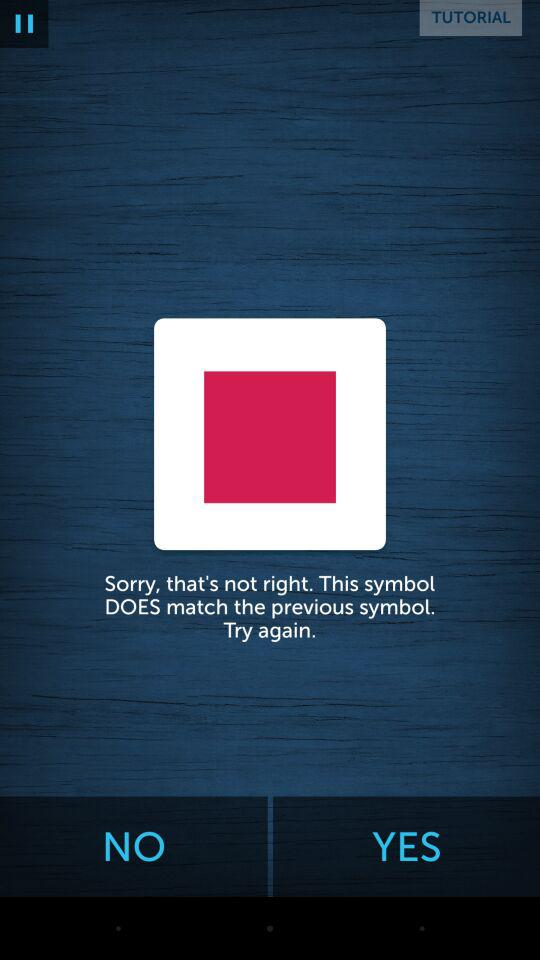What application is asking for permission? The application is "Lumosity". 